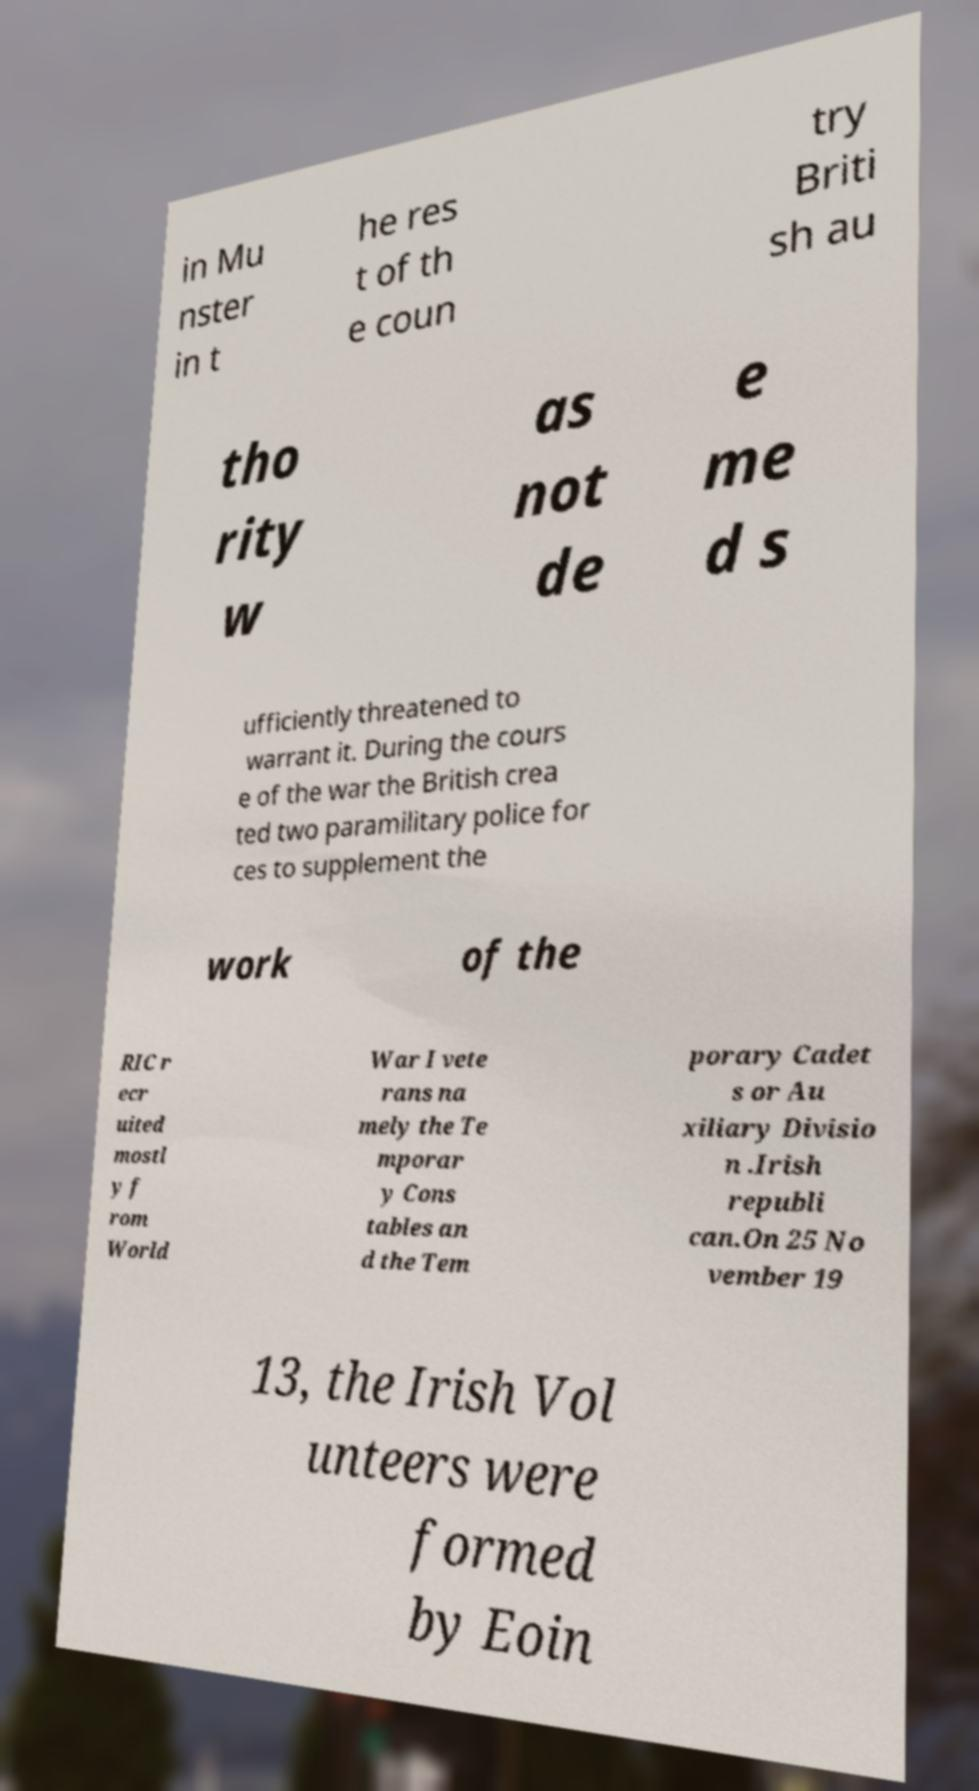Could you extract and type out the text from this image? in Mu nster in t he res t of th e coun try Briti sh au tho rity w as not de e me d s ufficiently threatened to warrant it. During the cours e of the war the British crea ted two paramilitary police for ces to supplement the work of the RIC r ecr uited mostl y f rom World War I vete rans na mely the Te mporar y Cons tables an d the Tem porary Cadet s or Au xiliary Divisio n .Irish republi can.On 25 No vember 19 13, the Irish Vol unteers were formed by Eoin 